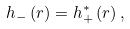<formula> <loc_0><loc_0><loc_500><loc_500>h _ { - } \left ( r \right ) = h _ { + } ^ { \ast } \left ( r \right ) ,</formula> 